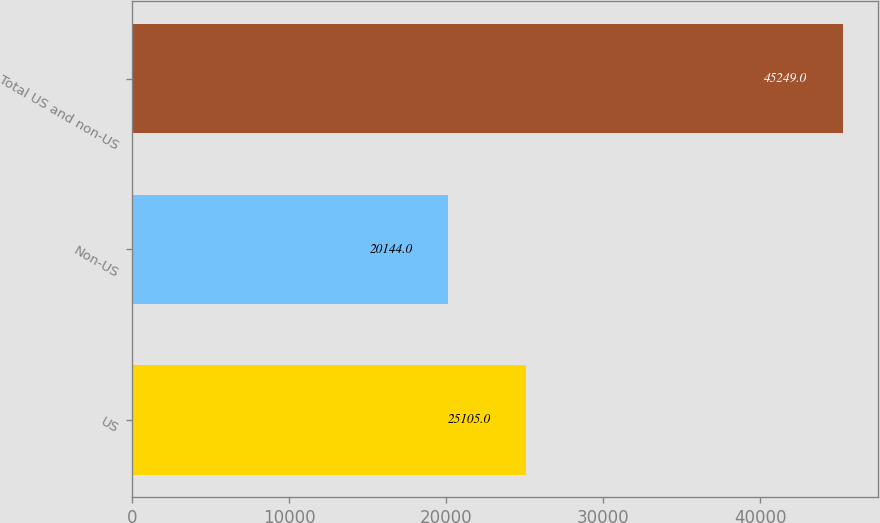<chart> <loc_0><loc_0><loc_500><loc_500><bar_chart><fcel>US<fcel>Non-US<fcel>Total US and non-US<nl><fcel>25105<fcel>20144<fcel>45249<nl></chart> 